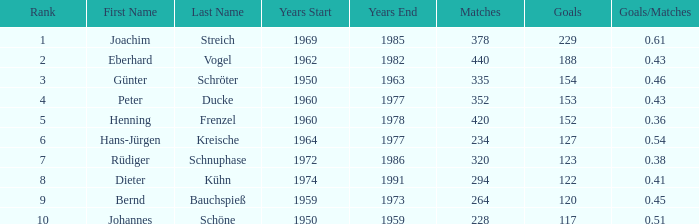What are the minimum objectives that have goals/games higher than None. 